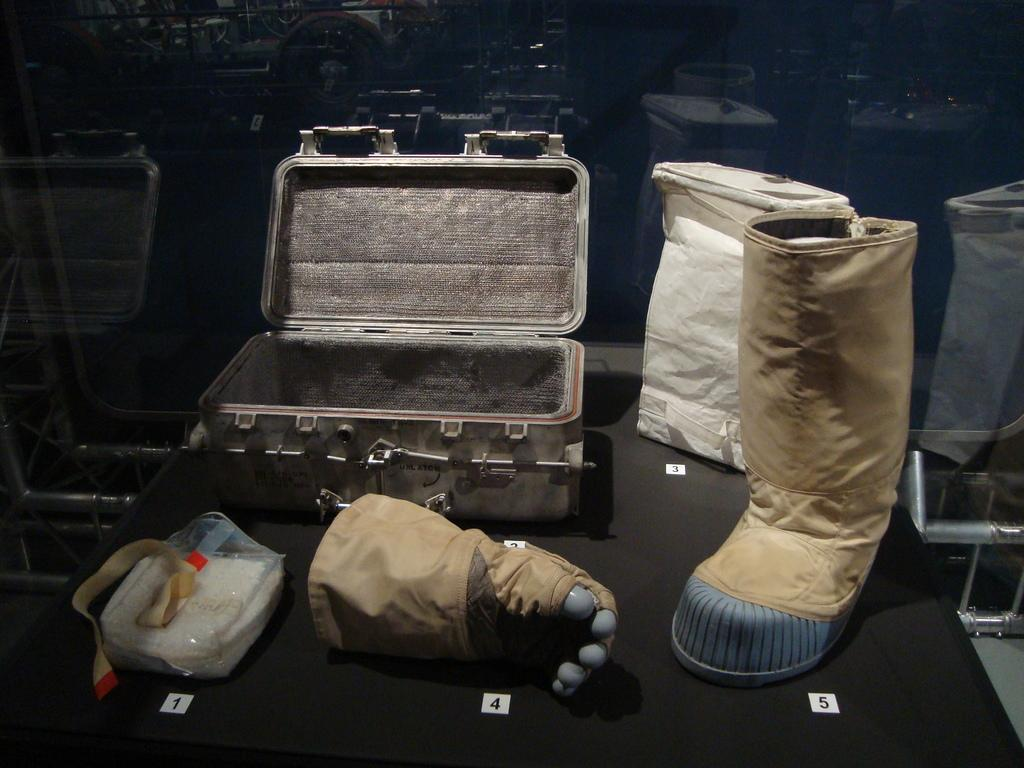What type of luggage can be seen in the image? There is a suitcase in the image. What type of clothing accessory is present in the image? There is a glove in the image. What type of protective covering is visible in the image? There is a plastic cover in the image. What type of footwear is present in the image? There is a gumboot in the image. Can you describe any other objects in the image? There are other unspecified objects in the image. How does the stranger interact with the gumboot in the image? There is no stranger present in the image, so it is not possible to answer that question. What type of insect can be seen buzzing around the glove in the image? There are no insects present in the image, so it is not possible to answer that question. 